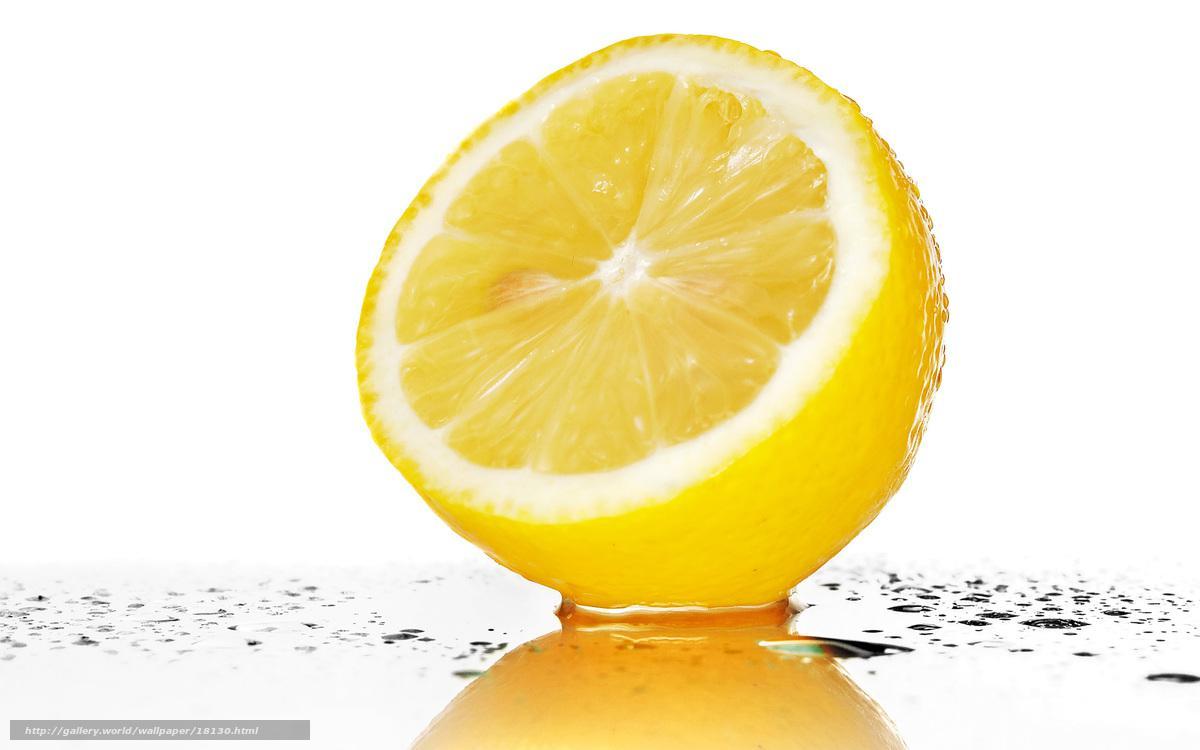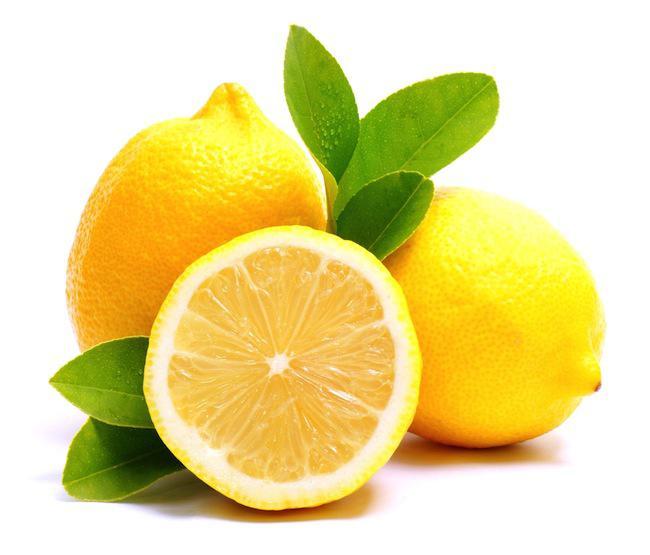The first image is the image on the left, the second image is the image on the right. Evaluate the accuracy of this statement regarding the images: "in the left image the lemons are left whole". Is it true? Answer yes or no. No. The first image is the image on the left, the second image is the image on the right. Evaluate the accuracy of this statement regarding the images: "There is one image with exactly five green leaves.". Is it true? Answer yes or no. Yes. 